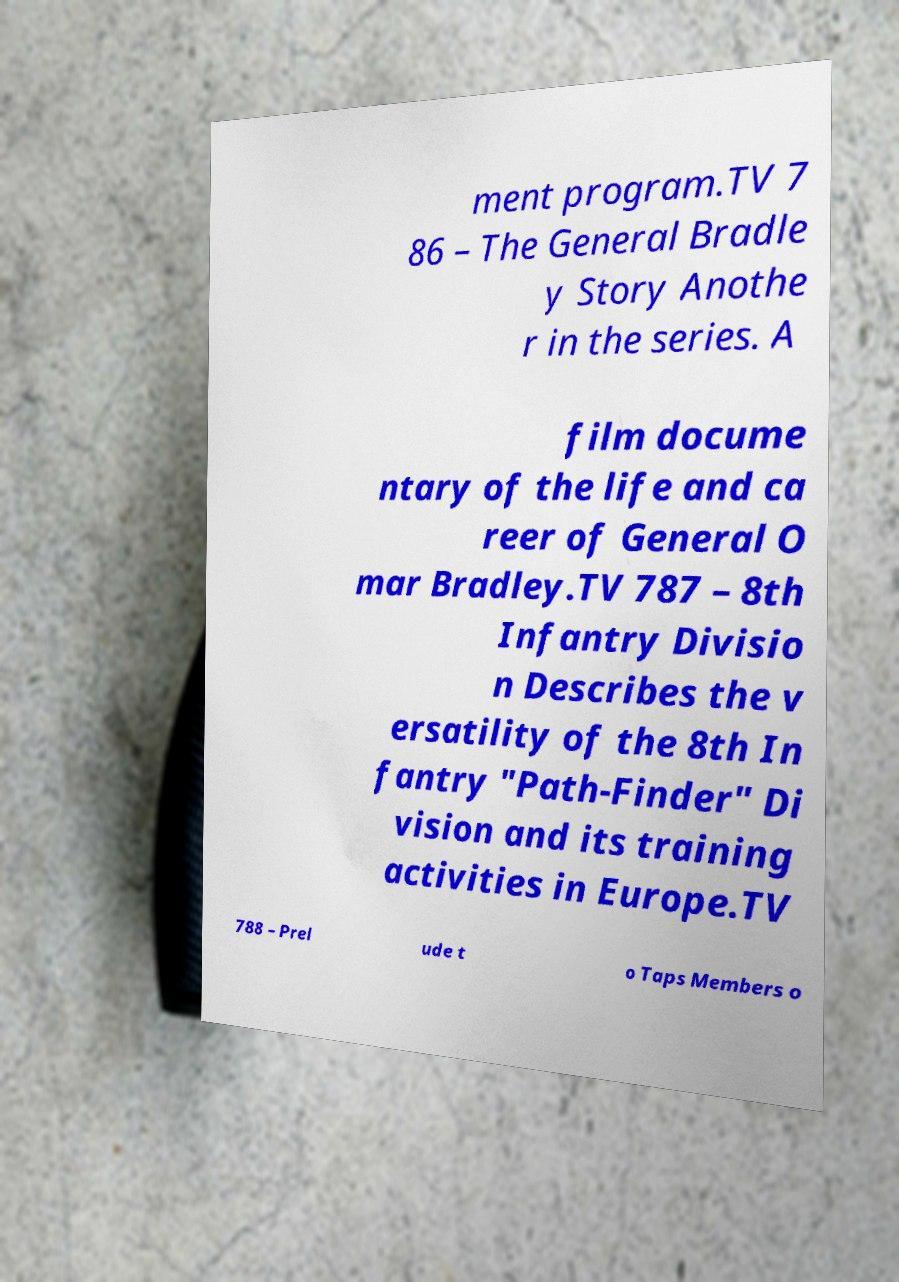For documentation purposes, I need the text within this image transcribed. Could you provide that? ment program.TV 7 86 – The General Bradle y Story Anothe r in the series. A film docume ntary of the life and ca reer of General O mar Bradley.TV 787 – 8th Infantry Divisio n Describes the v ersatility of the 8th In fantry "Path-Finder" Di vision and its training activities in Europe.TV 788 – Prel ude t o Taps Members o 